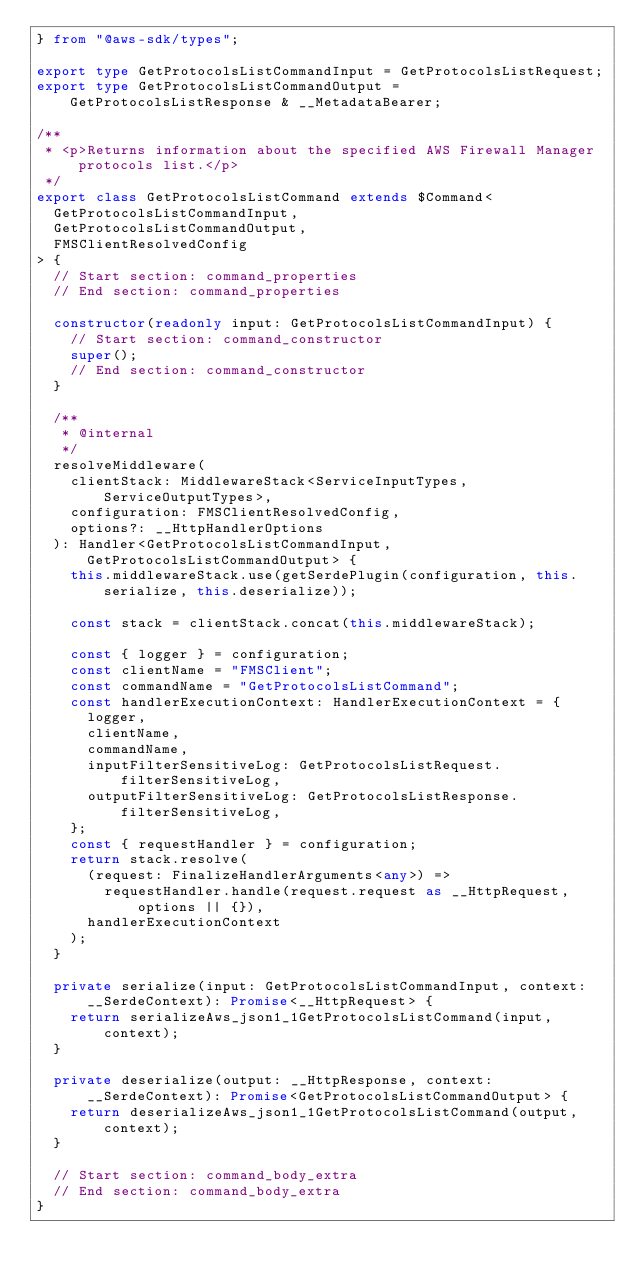<code> <loc_0><loc_0><loc_500><loc_500><_TypeScript_>} from "@aws-sdk/types";

export type GetProtocolsListCommandInput = GetProtocolsListRequest;
export type GetProtocolsListCommandOutput = GetProtocolsListResponse & __MetadataBearer;

/**
 * <p>Returns information about the specified AWS Firewall Manager protocols list.</p>
 */
export class GetProtocolsListCommand extends $Command<
  GetProtocolsListCommandInput,
  GetProtocolsListCommandOutput,
  FMSClientResolvedConfig
> {
  // Start section: command_properties
  // End section: command_properties

  constructor(readonly input: GetProtocolsListCommandInput) {
    // Start section: command_constructor
    super();
    // End section: command_constructor
  }

  /**
   * @internal
   */
  resolveMiddleware(
    clientStack: MiddlewareStack<ServiceInputTypes, ServiceOutputTypes>,
    configuration: FMSClientResolvedConfig,
    options?: __HttpHandlerOptions
  ): Handler<GetProtocolsListCommandInput, GetProtocolsListCommandOutput> {
    this.middlewareStack.use(getSerdePlugin(configuration, this.serialize, this.deserialize));

    const stack = clientStack.concat(this.middlewareStack);

    const { logger } = configuration;
    const clientName = "FMSClient";
    const commandName = "GetProtocolsListCommand";
    const handlerExecutionContext: HandlerExecutionContext = {
      logger,
      clientName,
      commandName,
      inputFilterSensitiveLog: GetProtocolsListRequest.filterSensitiveLog,
      outputFilterSensitiveLog: GetProtocolsListResponse.filterSensitiveLog,
    };
    const { requestHandler } = configuration;
    return stack.resolve(
      (request: FinalizeHandlerArguments<any>) =>
        requestHandler.handle(request.request as __HttpRequest, options || {}),
      handlerExecutionContext
    );
  }

  private serialize(input: GetProtocolsListCommandInput, context: __SerdeContext): Promise<__HttpRequest> {
    return serializeAws_json1_1GetProtocolsListCommand(input, context);
  }

  private deserialize(output: __HttpResponse, context: __SerdeContext): Promise<GetProtocolsListCommandOutput> {
    return deserializeAws_json1_1GetProtocolsListCommand(output, context);
  }

  // Start section: command_body_extra
  // End section: command_body_extra
}
</code> 